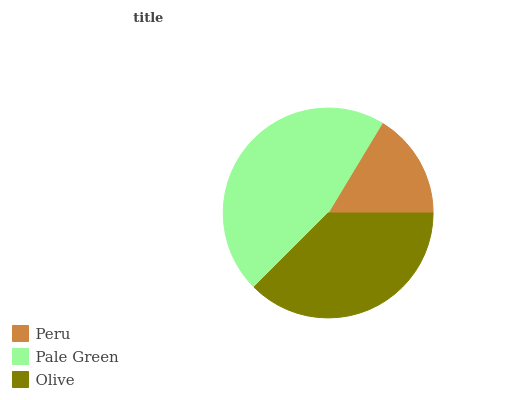Is Peru the minimum?
Answer yes or no. Yes. Is Pale Green the maximum?
Answer yes or no. Yes. Is Olive the minimum?
Answer yes or no. No. Is Olive the maximum?
Answer yes or no. No. Is Pale Green greater than Olive?
Answer yes or no. Yes. Is Olive less than Pale Green?
Answer yes or no. Yes. Is Olive greater than Pale Green?
Answer yes or no. No. Is Pale Green less than Olive?
Answer yes or no. No. Is Olive the high median?
Answer yes or no. Yes. Is Olive the low median?
Answer yes or no. Yes. Is Pale Green the high median?
Answer yes or no. No. Is Pale Green the low median?
Answer yes or no. No. 